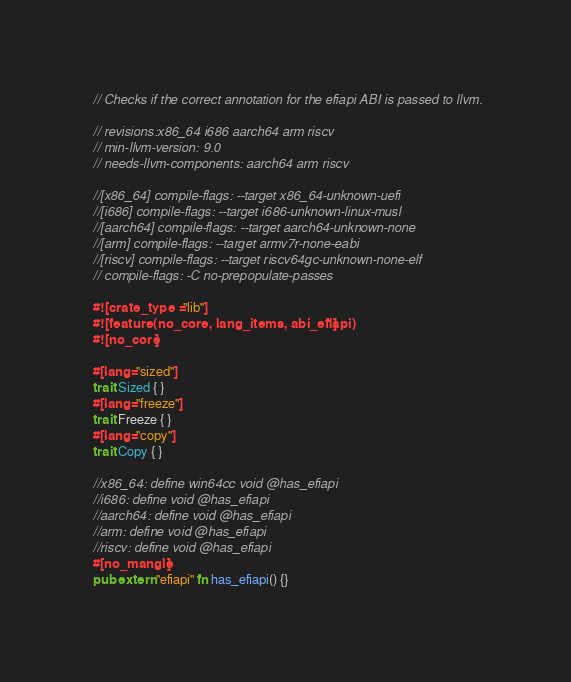<code> <loc_0><loc_0><loc_500><loc_500><_Rust_>// Checks if the correct annotation for the efiapi ABI is passed to llvm.

// revisions:x86_64 i686 aarch64 arm riscv
// min-llvm-version: 9.0
// needs-llvm-components: aarch64 arm riscv

//[x86_64] compile-flags: --target x86_64-unknown-uefi
//[i686] compile-flags: --target i686-unknown-linux-musl
//[aarch64] compile-flags: --target aarch64-unknown-none
//[arm] compile-flags: --target armv7r-none-eabi
//[riscv] compile-flags: --target riscv64gc-unknown-none-elf
// compile-flags: -C no-prepopulate-passes

#![crate_type = "lib"]
#![feature(no_core, lang_items, abi_efiapi)]
#![no_core]

#[lang="sized"]
trait Sized { }
#[lang="freeze"]
trait Freeze { }
#[lang="copy"]
trait Copy { }

//x86_64: define win64cc void @has_efiapi
//i686: define void @has_efiapi
//aarch64: define void @has_efiapi
//arm: define void @has_efiapi
//riscv: define void @has_efiapi
#[no_mangle]
pub extern "efiapi" fn has_efiapi() {}
</code> 